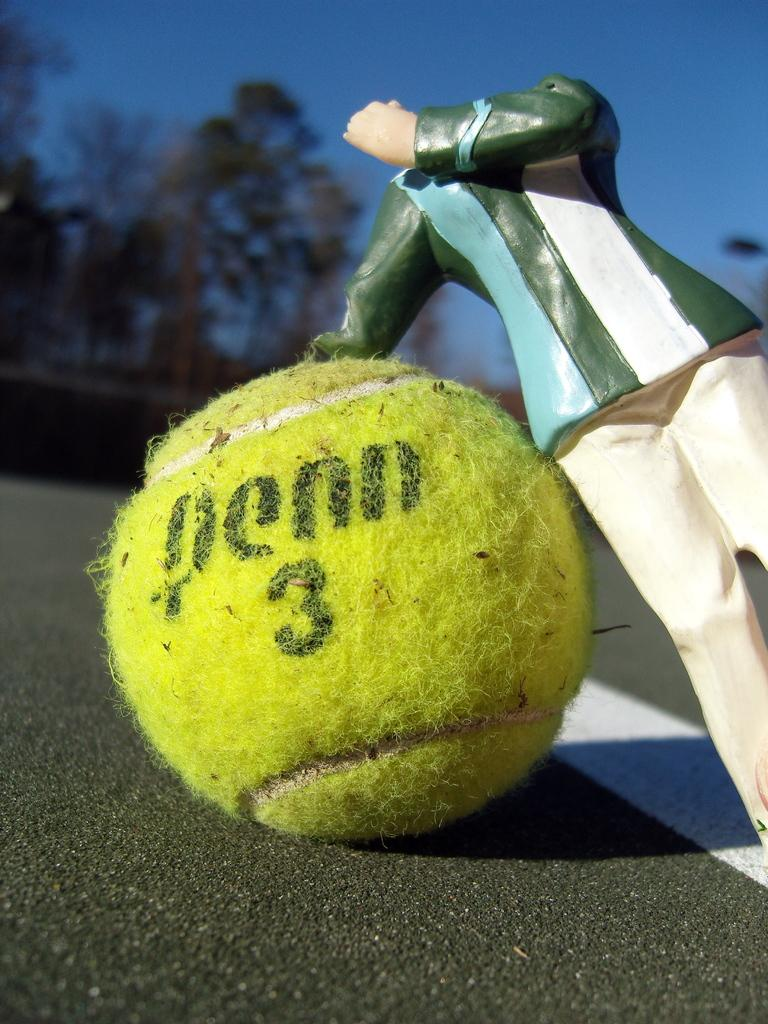Provide a one-sentence caption for the provided image. A headless action figure rests on a Penn 3 tennis ball. 